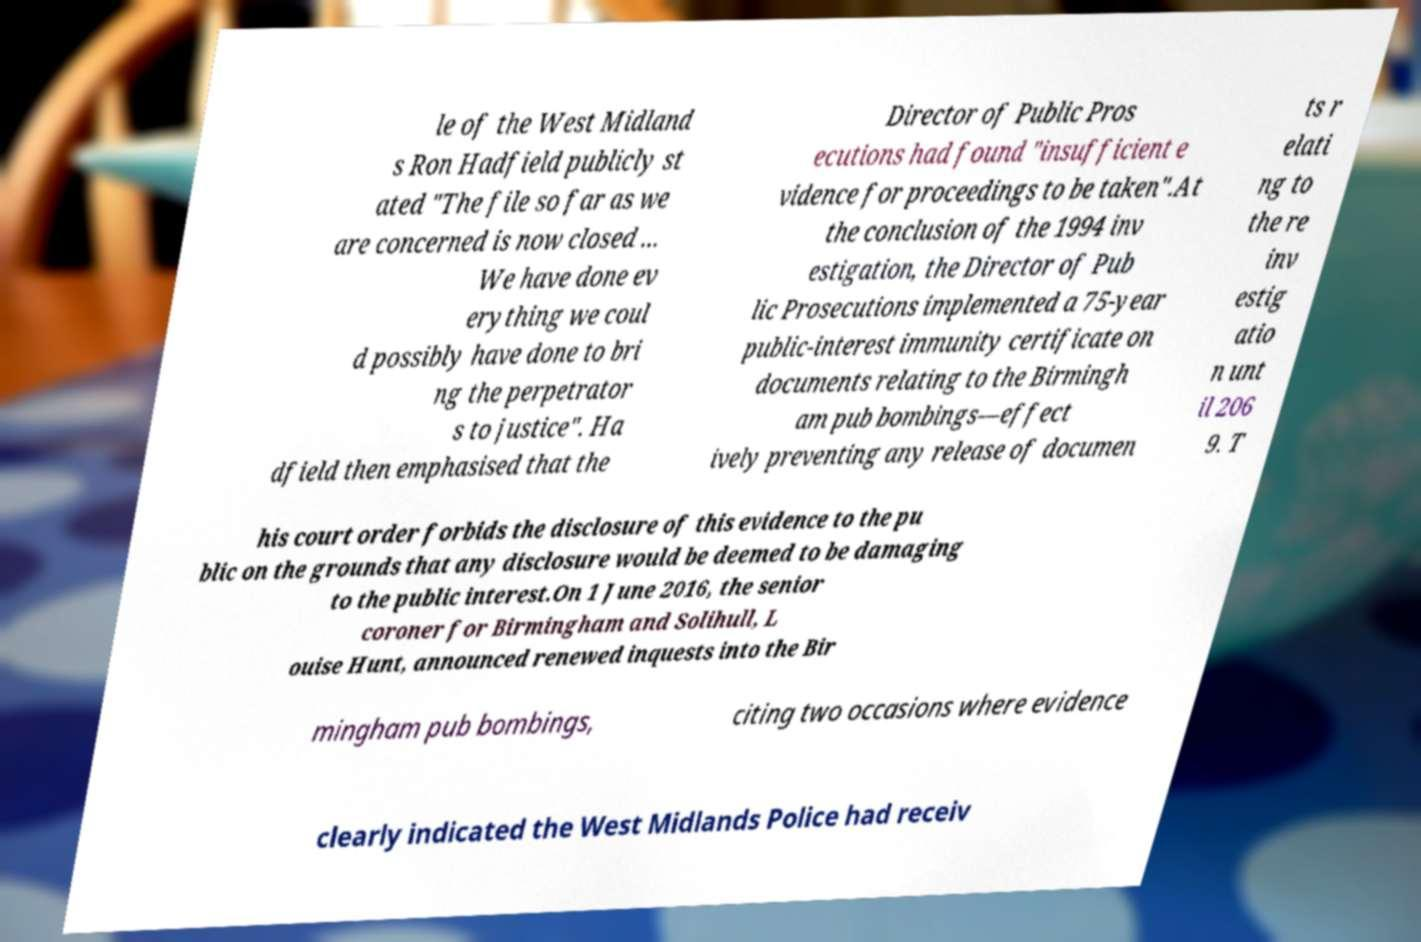There's text embedded in this image that I need extracted. Can you transcribe it verbatim? le of the West Midland s Ron Hadfield publicly st ated "The file so far as we are concerned is now closed ... We have done ev erything we coul d possibly have done to bri ng the perpetrator s to justice". Ha dfield then emphasised that the Director of Public Pros ecutions had found "insufficient e vidence for proceedings to be taken".At the conclusion of the 1994 inv estigation, the Director of Pub lic Prosecutions implemented a 75-year public-interest immunity certificate on documents relating to the Birmingh am pub bombings—effect ively preventing any release of documen ts r elati ng to the re inv estig atio n unt il 206 9. T his court order forbids the disclosure of this evidence to the pu blic on the grounds that any disclosure would be deemed to be damaging to the public interest.On 1 June 2016, the senior coroner for Birmingham and Solihull, L ouise Hunt, announced renewed inquests into the Bir mingham pub bombings, citing two occasions where evidence clearly indicated the West Midlands Police had receiv 